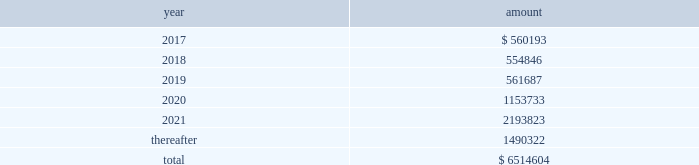New term loan a facility , with the remaining unpaid principal amount of loans under the new term loan a facility due and payable in full at maturity on june 6 , 2021 .
Principal amounts outstanding under the new revolving loan facility are due and payable in full at maturity on june 6 , 2021 , subject to earlier repayment pursuant to the springing maturity date described above .
In addition to paying interest on outstanding principal under the borrowings , we are obligated to pay a quarterly commitment fee at a rate determined by reference to a total leverage ratio , with a maximum commitment fee of 40% ( 40 % ) of the applicable margin for eurocurrency loans .
In july 2016 , breakaway four , ltd. , as borrower , and nclc , as guarantor , entered into a supplemental agreement , which amended the breakaway four loan to , among other things , increase the aggregate principal amount of commitments under the multi-draw term loan credit facility from 20ac590.5 million to 20ac729.9 million .
In june 2016 , we took delivery of seven seas explorer .
To finance the payment due upon delivery , we had export credit financing in place for 80% ( 80 % ) of the contract price .
The associated $ 373.6 million term loan bears interest at 3.43% ( 3.43 % ) with a maturity date of june 30 , 2028 .
Principal and interest payments shall be paid semiannually .
In december 2016 , nclc issued $ 700.0 million aggregate principal amount of 4.750% ( 4.750 % ) senior unsecured notes due december 2021 ( the 201cnotes 201d ) in a private offering ( the 201coffering 201d ) at par .
Nclc used the net proceeds from the offering , after deducting the initial purchasers 2019 discount and estimated fees and expenses , together with cash on hand , to purchase its outstanding 5.25% ( 5.25 % ) senior notes due 2019 having an aggregate outstanding principal amount of $ 680 million .
The redemption of the 5.25% ( 5.25 % ) senior notes due 2019 was completed in january 2017 .
Nclc will pay interest on the notes at 4.750% ( 4.750 % ) per annum , semiannually on june 15 and december 15 of each year , commencing on june 15 , 2017 , to holders of record at the close of business on the immediately preceding june 1 and december 1 , respectively .
Nclc may redeem the notes , in whole or part , at any time prior to december 15 , 2018 , at a price equal to 100% ( 100 % ) of the principal amount of the notes redeemed plus accrued and unpaid interest to , but not including , the redemption date and a 201cmake-whole premium . 201d nclc may redeem the notes , in whole or in part , on or after december 15 , 2018 , at the redemption prices set forth in the indenture governing the notes .
At any time ( which may be more than once ) on or prior to december 15 , 2018 , nclc may choose to redeem up to 40% ( 40 % ) of the aggregate principal amount of the notes at a redemption price equal to 104.750% ( 104.750 % ) of the face amount thereof with an amount equal to the net proceeds of one or more equity offerings , so long as at least 60% ( 60 % ) of the aggregate principal amount of the notes issued remains outstanding following such redemption .
The indenture governing the notes contains covenants that limit nclc 2019s ability ( and its restricted subsidiaries 2019 ability ) to , among other things : ( i ) incur or guarantee additional indebtedness or issue certain preferred shares ; ( ii ) pay dividends and make certain other restricted payments ; ( iii ) create restrictions on the payment of dividends or other distributions to nclc from its restricted subsidiaries ; ( iv ) create liens on certain assets to secure debt ; ( v ) make certain investments ; ( vi ) engage in transactions with affiliates ; ( vii ) engage in sales of assets and subsidiary stock ; and ( viii ) transfer all or substantially all of its assets or enter into merger or consolidation transactions .
The indenture governing the notes also provides for events of default , which , if any of them occurs , would permit or require the principal , premium ( if any ) , interest and other monetary obligations on all of the then-outstanding notes to become due and payable immediately .
Interest expense , net for the year ended december 31 , 2016 was $ 276.9 million which included $ 34.7 million of amortization of deferred financing fees and a $ 27.7 million loss on extinguishment of debt .
Interest expense , net for the year ended december 31 , 2015 was $ 221.9 million which included $ 36.7 million of amortization of deferred financing fees and a $ 12.7 million loss on extinguishment of debt .
Interest expense , net for the year ended december 31 , 2014 was $ 151.8 million which included $ 32.3 million of amortization of deferred financing fees and $ 15.4 million of expenses related to financing transactions in connection with the acquisition of prestige .
Certain of our debt agreements contain covenants that , among other things , require us to maintain a minimum level of liquidity , as well as limit our net funded debt-to-capital ratio , maintain certain other ratios and restrict our ability to pay dividends .
Substantially all of our ships and other property and equipment are pledged as collateral for certain of our debt .
We believe we were in compliance with these covenants as of december 31 , 2016 .
The following are scheduled principal repayments on long-term debt including capital lease obligations as of december 31 , 2016 for each of the next five years ( in thousands ) : .
We had an accrued interest liability of $ 32.5 million and $ 34.2 million as of december 31 , 2016 and 2015 , respectively. .
What is the percentage change in accrued interest liability from 2015 to 2016? 
Computations: ((32.5 - 34.2) / 34.2)
Answer: -0.04971. 